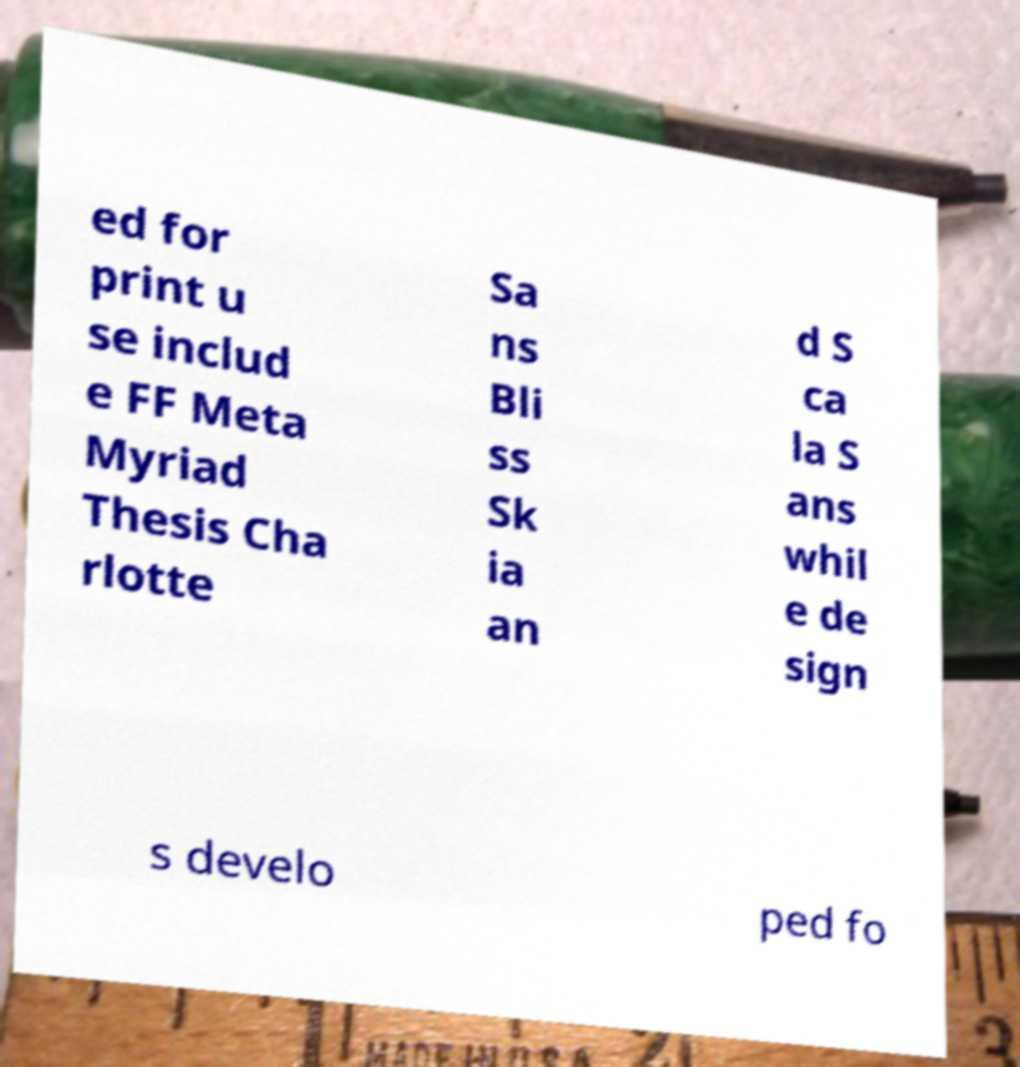I need the written content from this picture converted into text. Can you do that? ed for print u se includ e FF Meta Myriad Thesis Cha rlotte Sa ns Bli ss Sk ia an d S ca la S ans whil e de sign s develo ped fo 